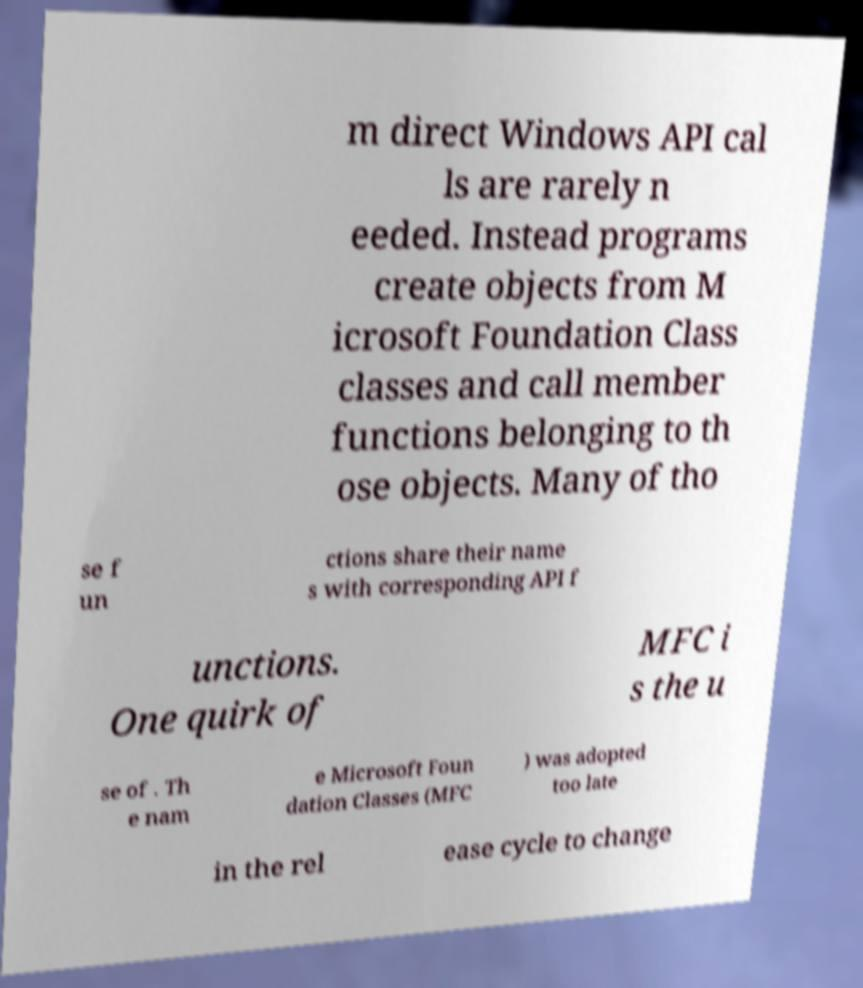For documentation purposes, I need the text within this image transcribed. Could you provide that? m direct Windows API cal ls are rarely n eeded. Instead programs create objects from M icrosoft Foundation Class classes and call member functions belonging to th ose objects. Many of tho se f un ctions share their name s with corresponding API f unctions. One quirk of MFC i s the u se of . Th e nam e Microsoft Foun dation Classes (MFC ) was adopted too late in the rel ease cycle to change 